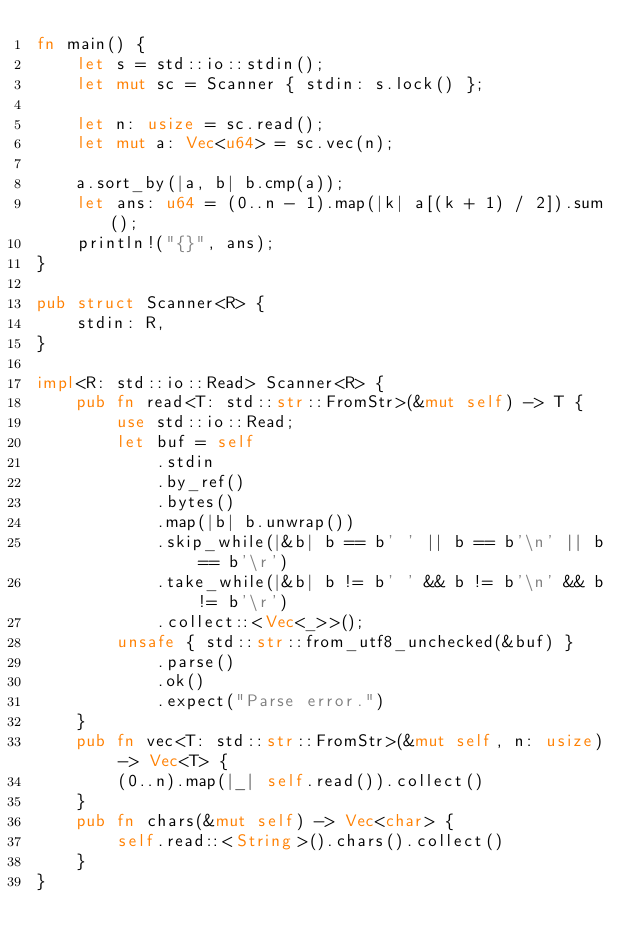<code> <loc_0><loc_0><loc_500><loc_500><_Rust_>fn main() {
    let s = std::io::stdin();
    let mut sc = Scanner { stdin: s.lock() };

    let n: usize = sc.read();
    let mut a: Vec<u64> = sc.vec(n);

    a.sort_by(|a, b| b.cmp(a));
    let ans: u64 = (0..n - 1).map(|k| a[(k + 1) / 2]).sum();
    println!("{}", ans);
}

pub struct Scanner<R> {
    stdin: R,
}

impl<R: std::io::Read> Scanner<R> {
    pub fn read<T: std::str::FromStr>(&mut self) -> T {
        use std::io::Read;
        let buf = self
            .stdin
            .by_ref()
            .bytes()
            .map(|b| b.unwrap())
            .skip_while(|&b| b == b' ' || b == b'\n' || b == b'\r')
            .take_while(|&b| b != b' ' && b != b'\n' && b != b'\r')
            .collect::<Vec<_>>();
        unsafe { std::str::from_utf8_unchecked(&buf) }
            .parse()
            .ok()
            .expect("Parse error.")
    }
    pub fn vec<T: std::str::FromStr>(&mut self, n: usize) -> Vec<T> {
        (0..n).map(|_| self.read()).collect()
    }
    pub fn chars(&mut self) -> Vec<char> {
        self.read::<String>().chars().collect()
    }
}</code> 